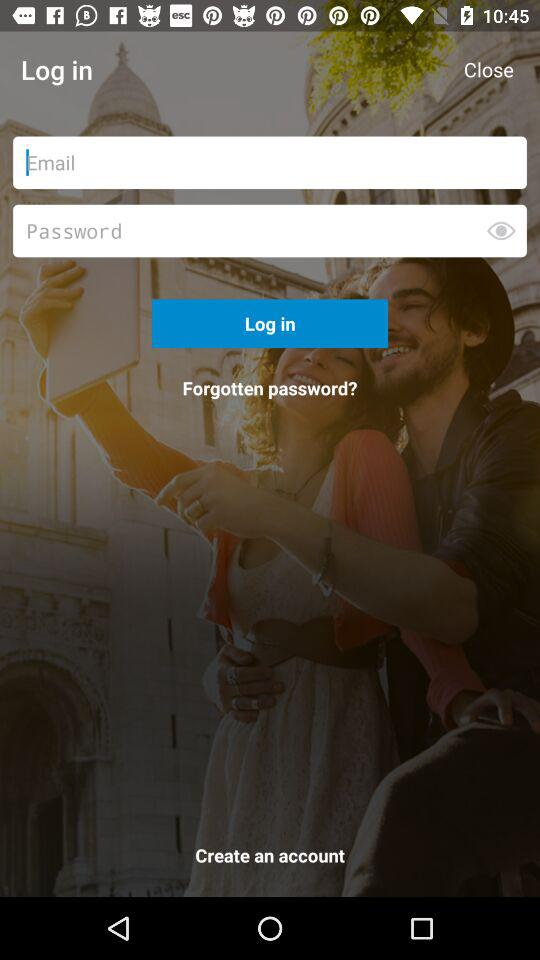What are the requirements to log in? The requirements are "Email" and "Password". 